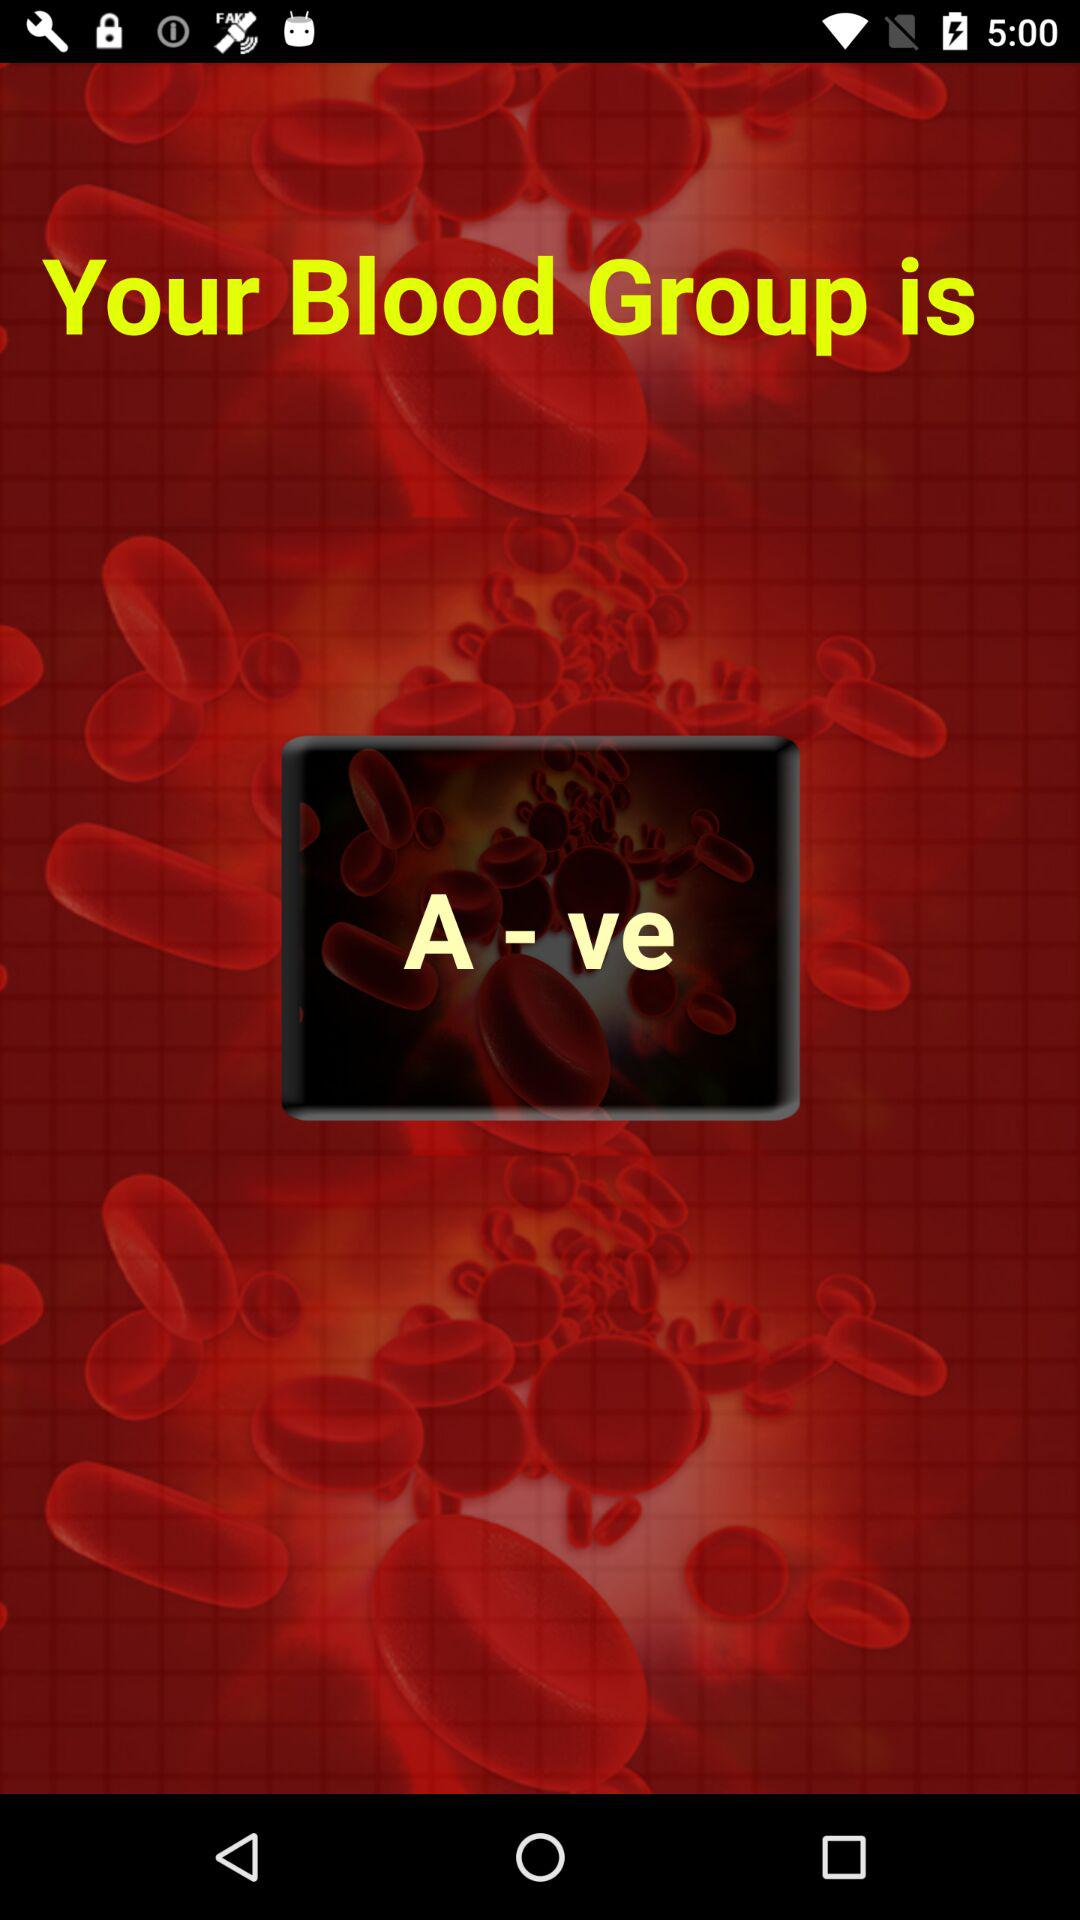Who is the user?
When the provided information is insufficient, respond with <no answer>. <no answer> 